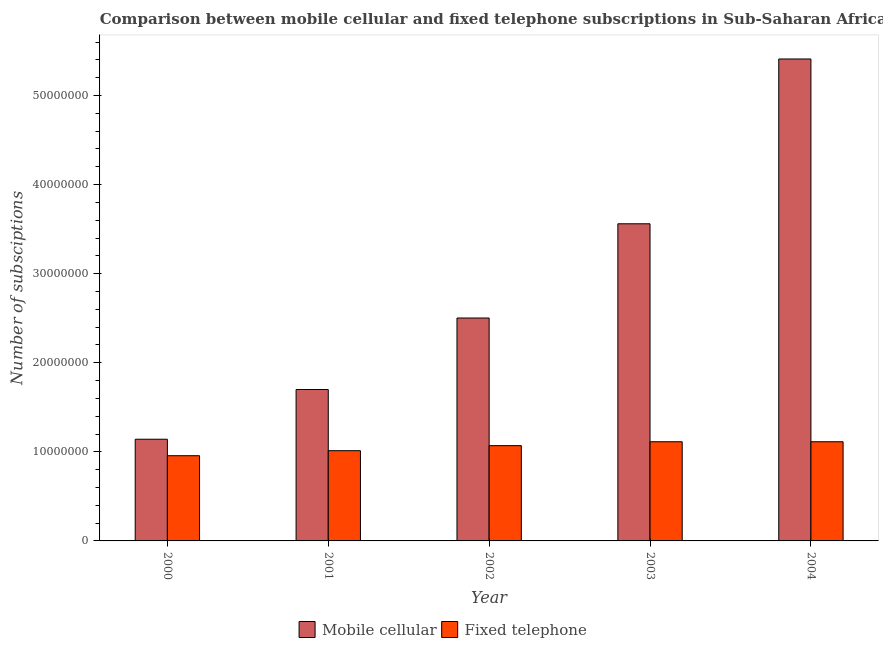How many different coloured bars are there?
Your response must be concise. 2. Are the number of bars on each tick of the X-axis equal?
Make the answer very short. Yes. How many bars are there on the 3rd tick from the left?
Provide a succinct answer. 2. In how many cases, is the number of bars for a given year not equal to the number of legend labels?
Your answer should be very brief. 0. What is the number of fixed telephone subscriptions in 2002?
Offer a terse response. 1.07e+07. Across all years, what is the maximum number of fixed telephone subscriptions?
Offer a terse response. 1.11e+07. Across all years, what is the minimum number of fixed telephone subscriptions?
Provide a short and direct response. 9.56e+06. What is the total number of fixed telephone subscriptions in the graph?
Provide a succinct answer. 5.26e+07. What is the difference between the number of fixed telephone subscriptions in 2000 and that in 2001?
Your answer should be compact. -5.63e+05. What is the difference between the number of mobile cellular subscriptions in 2003 and the number of fixed telephone subscriptions in 2002?
Provide a succinct answer. 1.06e+07. What is the average number of fixed telephone subscriptions per year?
Give a very brief answer. 1.05e+07. What is the ratio of the number of mobile cellular subscriptions in 2000 to that in 2002?
Give a very brief answer. 0.46. Is the difference between the number of fixed telephone subscriptions in 2000 and 2001 greater than the difference between the number of mobile cellular subscriptions in 2000 and 2001?
Provide a short and direct response. No. What is the difference between the highest and the second highest number of fixed telephone subscriptions?
Offer a very short reply. 250. What is the difference between the highest and the lowest number of fixed telephone subscriptions?
Ensure brevity in your answer.  1.57e+06. In how many years, is the number of fixed telephone subscriptions greater than the average number of fixed telephone subscriptions taken over all years?
Ensure brevity in your answer.  3. What does the 2nd bar from the left in 2003 represents?
Provide a succinct answer. Fixed telephone. What does the 2nd bar from the right in 2003 represents?
Provide a short and direct response. Mobile cellular. Are all the bars in the graph horizontal?
Your answer should be compact. No. How many years are there in the graph?
Give a very brief answer. 5. Are the values on the major ticks of Y-axis written in scientific E-notation?
Provide a succinct answer. No. How many legend labels are there?
Your response must be concise. 2. How are the legend labels stacked?
Your response must be concise. Horizontal. What is the title of the graph?
Keep it short and to the point. Comparison between mobile cellular and fixed telephone subscriptions in Sub-Saharan Africa (developing only). What is the label or title of the X-axis?
Offer a terse response. Year. What is the label or title of the Y-axis?
Make the answer very short. Number of subsciptions. What is the Number of subsciptions in Mobile cellular in 2000?
Offer a terse response. 1.14e+07. What is the Number of subsciptions in Fixed telephone in 2000?
Make the answer very short. 9.56e+06. What is the Number of subsciptions in Mobile cellular in 2001?
Provide a short and direct response. 1.70e+07. What is the Number of subsciptions in Fixed telephone in 2001?
Your answer should be very brief. 1.01e+07. What is the Number of subsciptions in Mobile cellular in 2002?
Your answer should be compact. 2.50e+07. What is the Number of subsciptions in Fixed telephone in 2002?
Provide a succinct answer. 1.07e+07. What is the Number of subsciptions in Mobile cellular in 2003?
Offer a very short reply. 3.56e+07. What is the Number of subsciptions in Fixed telephone in 2003?
Offer a terse response. 1.11e+07. What is the Number of subsciptions of Mobile cellular in 2004?
Provide a succinct answer. 5.41e+07. What is the Number of subsciptions of Fixed telephone in 2004?
Your response must be concise. 1.11e+07. Across all years, what is the maximum Number of subsciptions in Mobile cellular?
Keep it short and to the point. 5.41e+07. Across all years, what is the maximum Number of subsciptions of Fixed telephone?
Keep it short and to the point. 1.11e+07. Across all years, what is the minimum Number of subsciptions of Mobile cellular?
Your answer should be compact. 1.14e+07. Across all years, what is the minimum Number of subsciptions in Fixed telephone?
Ensure brevity in your answer.  9.56e+06. What is the total Number of subsciptions in Mobile cellular in the graph?
Give a very brief answer. 1.43e+08. What is the total Number of subsciptions of Fixed telephone in the graph?
Offer a terse response. 5.26e+07. What is the difference between the Number of subsciptions of Mobile cellular in 2000 and that in 2001?
Offer a terse response. -5.58e+06. What is the difference between the Number of subsciptions of Fixed telephone in 2000 and that in 2001?
Your answer should be compact. -5.63e+05. What is the difference between the Number of subsciptions of Mobile cellular in 2000 and that in 2002?
Keep it short and to the point. -1.36e+07. What is the difference between the Number of subsciptions in Fixed telephone in 2000 and that in 2002?
Provide a short and direct response. -1.13e+06. What is the difference between the Number of subsciptions in Mobile cellular in 2000 and that in 2003?
Keep it short and to the point. -2.42e+07. What is the difference between the Number of subsciptions of Fixed telephone in 2000 and that in 2003?
Ensure brevity in your answer.  -1.57e+06. What is the difference between the Number of subsciptions in Mobile cellular in 2000 and that in 2004?
Your answer should be very brief. -4.27e+07. What is the difference between the Number of subsciptions in Fixed telephone in 2000 and that in 2004?
Offer a very short reply. -1.57e+06. What is the difference between the Number of subsciptions of Mobile cellular in 2001 and that in 2002?
Your response must be concise. -8.03e+06. What is the difference between the Number of subsciptions in Fixed telephone in 2001 and that in 2002?
Ensure brevity in your answer.  -5.66e+05. What is the difference between the Number of subsciptions in Mobile cellular in 2001 and that in 2003?
Make the answer very short. -1.86e+07. What is the difference between the Number of subsciptions in Fixed telephone in 2001 and that in 2003?
Give a very brief answer. -1.00e+06. What is the difference between the Number of subsciptions in Mobile cellular in 2001 and that in 2004?
Your answer should be very brief. -3.71e+07. What is the difference between the Number of subsciptions in Fixed telephone in 2001 and that in 2004?
Offer a very short reply. -1.00e+06. What is the difference between the Number of subsciptions in Mobile cellular in 2002 and that in 2003?
Ensure brevity in your answer.  -1.06e+07. What is the difference between the Number of subsciptions in Fixed telephone in 2002 and that in 2003?
Provide a short and direct response. -4.38e+05. What is the difference between the Number of subsciptions in Mobile cellular in 2002 and that in 2004?
Provide a short and direct response. -2.91e+07. What is the difference between the Number of subsciptions of Fixed telephone in 2002 and that in 2004?
Keep it short and to the point. -4.38e+05. What is the difference between the Number of subsciptions of Mobile cellular in 2003 and that in 2004?
Give a very brief answer. -1.85e+07. What is the difference between the Number of subsciptions of Fixed telephone in 2003 and that in 2004?
Offer a very short reply. 250. What is the difference between the Number of subsciptions in Mobile cellular in 2000 and the Number of subsciptions in Fixed telephone in 2001?
Your answer should be compact. 1.29e+06. What is the difference between the Number of subsciptions of Mobile cellular in 2000 and the Number of subsciptions of Fixed telephone in 2002?
Your answer should be compact. 7.21e+05. What is the difference between the Number of subsciptions in Mobile cellular in 2000 and the Number of subsciptions in Fixed telephone in 2003?
Your response must be concise. 2.82e+05. What is the difference between the Number of subsciptions in Mobile cellular in 2000 and the Number of subsciptions in Fixed telephone in 2004?
Provide a short and direct response. 2.83e+05. What is the difference between the Number of subsciptions in Mobile cellular in 2001 and the Number of subsciptions in Fixed telephone in 2002?
Provide a succinct answer. 6.30e+06. What is the difference between the Number of subsciptions in Mobile cellular in 2001 and the Number of subsciptions in Fixed telephone in 2003?
Make the answer very short. 5.86e+06. What is the difference between the Number of subsciptions of Mobile cellular in 2001 and the Number of subsciptions of Fixed telephone in 2004?
Your answer should be compact. 5.86e+06. What is the difference between the Number of subsciptions in Mobile cellular in 2002 and the Number of subsciptions in Fixed telephone in 2003?
Offer a very short reply. 1.39e+07. What is the difference between the Number of subsciptions in Mobile cellular in 2002 and the Number of subsciptions in Fixed telephone in 2004?
Offer a very short reply. 1.39e+07. What is the difference between the Number of subsciptions of Mobile cellular in 2003 and the Number of subsciptions of Fixed telephone in 2004?
Your response must be concise. 2.45e+07. What is the average Number of subsciptions of Mobile cellular per year?
Keep it short and to the point. 2.86e+07. What is the average Number of subsciptions of Fixed telephone per year?
Your response must be concise. 1.05e+07. In the year 2000, what is the difference between the Number of subsciptions of Mobile cellular and Number of subsciptions of Fixed telephone?
Provide a short and direct response. 1.85e+06. In the year 2001, what is the difference between the Number of subsciptions in Mobile cellular and Number of subsciptions in Fixed telephone?
Make the answer very short. 6.87e+06. In the year 2002, what is the difference between the Number of subsciptions in Mobile cellular and Number of subsciptions in Fixed telephone?
Offer a very short reply. 1.43e+07. In the year 2003, what is the difference between the Number of subsciptions of Mobile cellular and Number of subsciptions of Fixed telephone?
Provide a short and direct response. 2.45e+07. In the year 2004, what is the difference between the Number of subsciptions in Mobile cellular and Number of subsciptions in Fixed telephone?
Provide a short and direct response. 4.30e+07. What is the ratio of the Number of subsciptions of Mobile cellular in 2000 to that in 2001?
Your answer should be very brief. 0.67. What is the ratio of the Number of subsciptions of Fixed telephone in 2000 to that in 2001?
Your answer should be compact. 0.94. What is the ratio of the Number of subsciptions of Mobile cellular in 2000 to that in 2002?
Make the answer very short. 0.46. What is the ratio of the Number of subsciptions in Fixed telephone in 2000 to that in 2002?
Provide a succinct answer. 0.89. What is the ratio of the Number of subsciptions in Mobile cellular in 2000 to that in 2003?
Provide a short and direct response. 0.32. What is the ratio of the Number of subsciptions in Fixed telephone in 2000 to that in 2003?
Make the answer very short. 0.86. What is the ratio of the Number of subsciptions of Mobile cellular in 2000 to that in 2004?
Ensure brevity in your answer.  0.21. What is the ratio of the Number of subsciptions of Fixed telephone in 2000 to that in 2004?
Your response must be concise. 0.86. What is the ratio of the Number of subsciptions of Mobile cellular in 2001 to that in 2002?
Ensure brevity in your answer.  0.68. What is the ratio of the Number of subsciptions in Fixed telephone in 2001 to that in 2002?
Ensure brevity in your answer.  0.95. What is the ratio of the Number of subsciptions of Mobile cellular in 2001 to that in 2003?
Your answer should be very brief. 0.48. What is the ratio of the Number of subsciptions in Fixed telephone in 2001 to that in 2003?
Give a very brief answer. 0.91. What is the ratio of the Number of subsciptions of Mobile cellular in 2001 to that in 2004?
Ensure brevity in your answer.  0.31. What is the ratio of the Number of subsciptions of Fixed telephone in 2001 to that in 2004?
Keep it short and to the point. 0.91. What is the ratio of the Number of subsciptions in Mobile cellular in 2002 to that in 2003?
Provide a succinct answer. 0.7. What is the ratio of the Number of subsciptions in Fixed telephone in 2002 to that in 2003?
Offer a terse response. 0.96. What is the ratio of the Number of subsciptions in Mobile cellular in 2002 to that in 2004?
Keep it short and to the point. 0.46. What is the ratio of the Number of subsciptions in Fixed telephone in 2002 to that in 2004?
Provide a short and direct response. 0.96. What is the ratio of the Number of subsciptions of Mobile cellular in 2003 to that in 2004?
Offer a very short reply. 0.66. What is the ratio of the Number of subsciptions in Fixed telephone in 2003 to that in 2004?
Give a very brief answer. 1. What is the difference between the highest and the second highest Number of subsciptions of Mobile cellular?
Provide a succinct answer. 1.85e+07. What is the difference between the highest and the second highest Number of subsciptions of Fixed telephone?
Ensure brevity in your answer.  250. What is the difference between the highest and the lowest Number of subsciptions in Mobile cellular?
Your answer should be very brief. 4.27e+07. What is the difference between the highest and the lowest Number of subsciptions of Fixed telephone?
Make the answer very short. 1.57e+06. 